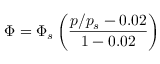<formula> <loc_0><loc_0><loc_500><loc_500>\Phi = \Phi _ { s } \left ( \frac { p / p _ { s } - 0 . 0 2 } { 1 - 0 . 0 2 } \right )</formula> 